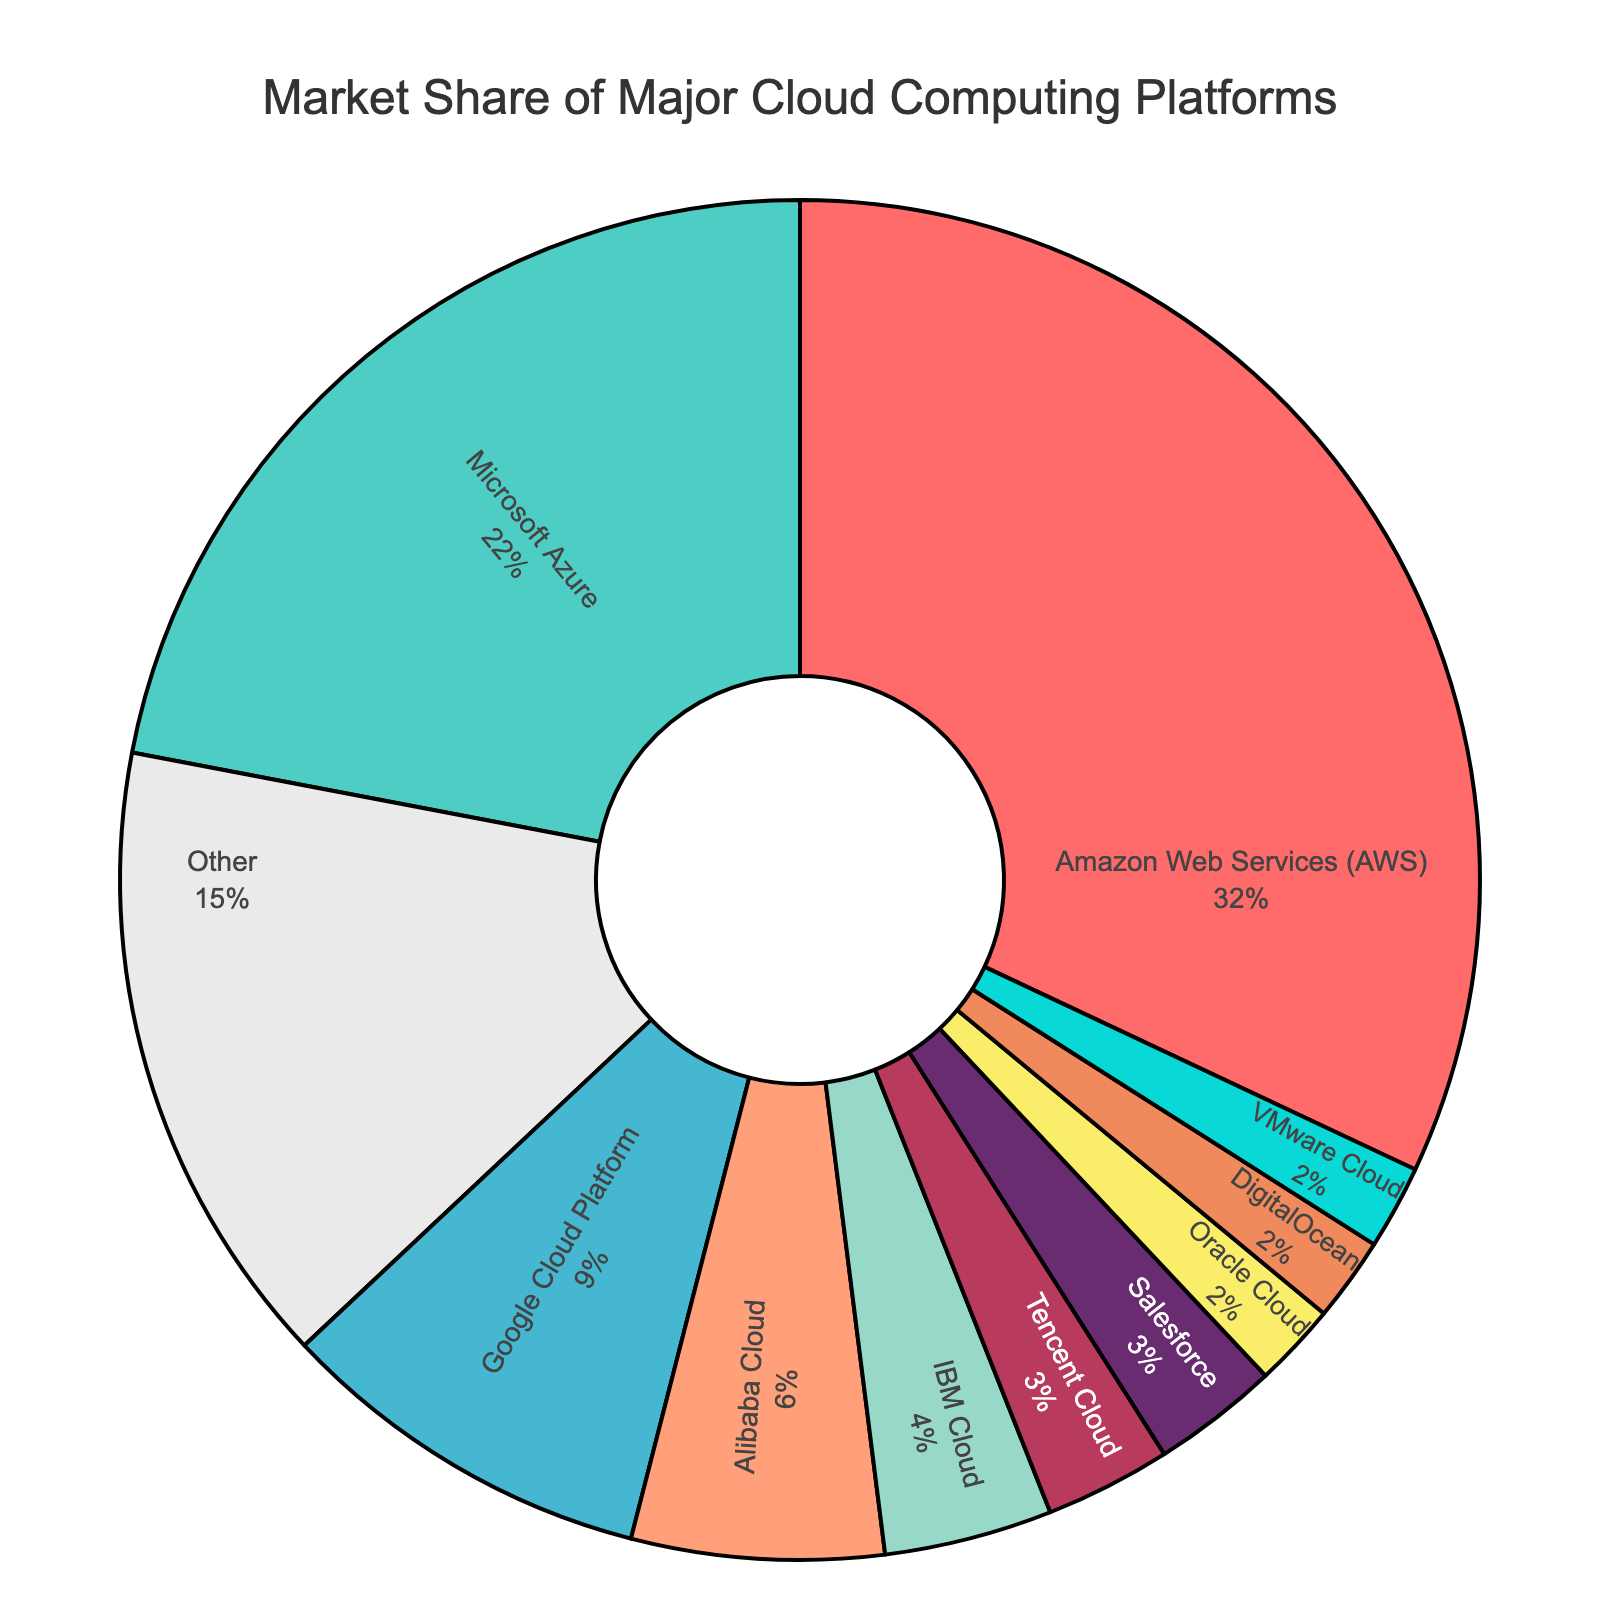Which cloud provider has the largest market share? AWS has the largest market share, which is 32%.
Answer: AWS What is the combined market share of Google Cloud Platform and IBM Cloud? Google Cloud Platform has a market share of 9%, and IBM Cloud has a market share of 4%. The combined market share is 9% + 4% = 13%.
Answer: 13% How much bigger is Microsoft's market share compared to Oracle's? Microsoft Azure has a market share of 22%, while Oracle Cloud has a market share of 2%. The difference is 22% - 2% = 20%.
Answer: 20% Which cloud providers have an equal market share? Oracle Cloud, DigitalOcean, and VMware Cloud each have a market share of 2%.
Answer: Oracle Cloud, DigitalOcean, VMware Cloud What's the total market share of the top three providers combined? The top three providers are AWS (32%), Microsoft Azure (22%), and Google Cloud Platform (9%). The total market share is 32% + 22% + 9% = 63%.
Answer: 63% Which cloud provider has the smallest market share, and what is it? Oracle Cloud, DigitalOcean, and VMware Cloud each have the smallest market share, which is 2%.
Answer: Oracle Cloud, DigitalOcean, VMware Cloud How does Alibaba Cloud's market share compare to Tencent Cloud's? Alibaba Cloud has a market share of 6%, while Tencent Cloud has a market share of 3%. Therefore, Alibaba Cloud's market share is twice as large as Tencent Cloud's.
Answer: Alibaba Cloud's share is twice as large as Tencent Cloud's Which section of the pie chart is colored red? The section colored red represents Amazon Web Services (AWS), which has a market share of 32%.
Answer: AWS What is the market share of providers categorized as 'Other'? The market share of providers categorized as 'Other' is 15%.
Answer: 15% If Salesforce and VMware Cloud combined their market shares, what would their total market share be? Salesforce has a market share of 3%, and VMware Cloud has a market share of 2%. Their combined market share would be 3% + 2% = 5%.
Answer: 5% 